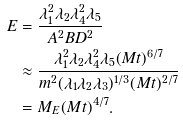Convert formula to latex. <formula><loc_0><loc_0><loc_500><loc_500>E & = \frac { \lambda _ { 1 } ^ { 2 } \lambda _ { 2 } \lambda _ { 4 } ^ { 2 } \lambda _ { 5 } } { A ^ { 2 } B D ^ { 2 } } \\ & \approx \frac { \lambda _ { 1 } ^ { 2 } \lambda _ { 2 } \lambda _ { 4 } ^ { 2 } \lambda _ { 5 } ( M t ) ^ { 6 / 7 } } { m ^ { 2 } ( \lambda _ { 1 } \lambda _ { 2 } \lambda _ { 3 } ) ^ { 1 / 3 } ( M t ) ^ { 2 / 7 } } \\ & = M _ { E } ( M t ) ^ { 4 / 7 } .</formula> 